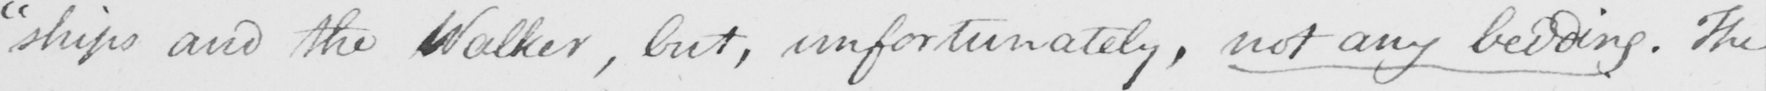Can you tell me what this handwritten text says? " ships and the Walker , but , unfortunately , not any bedding . The 